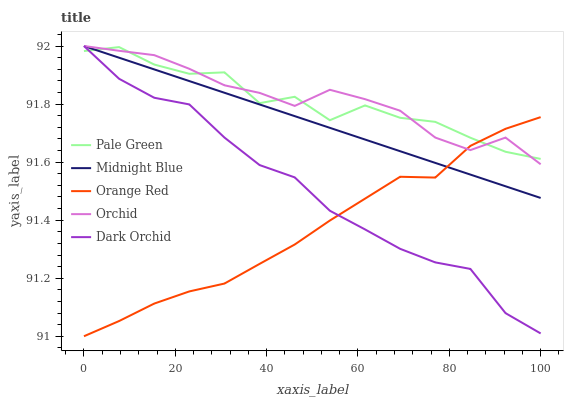Does Orange Red have the minimum area under the curve?
Answer yes or no. Yes. Does Orchid have the maximum area under the curve?
Answer yes or no. Yes. Does Pale Green have the minimum area under the curve?
Answer yes or no. No. Does Pale Green have the maximum area under the curve?
Answer yes or no. No. Is Midnight Blue the smoothest?
Answer yes or no. Yes. Is Pale Green the roughest?
Answer yes or no. Yes. Is Pale Green the smoothest?
Answer yes or no. No. Is Midnight Blue the roughest?
Answer yes or no. No. Does Orange Red have the lowest value?
Answer yes or no. Yes. Does Midnight Blue have the lowest value?
Answer yes or no. No. Does Dark Orchid have the highest value?
Answer yes or no. Yes. Does Pale Green have the highest value?
Answer yes or no. No. Does Dark Orchid intersect Pale Green?
Answer yes or no. Yes. Is Dark Orchid less than Pale Green?
Answer yes or no. No. Is Dark Orchid greater than Pale Green?
Answer yes or no. No. 